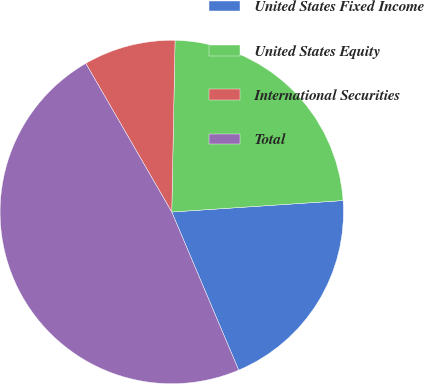<chart> <loc_0><loc_0><loc_500><loc_500><pie_chart><fcel>United States Fixed Income<fcel>United States Equity<fcel>International Securities<fcel>Total<nl><fcel>19.69%<fcel>23.63%<fcel>8.65%<fcel>48.03%<nl></chart> 